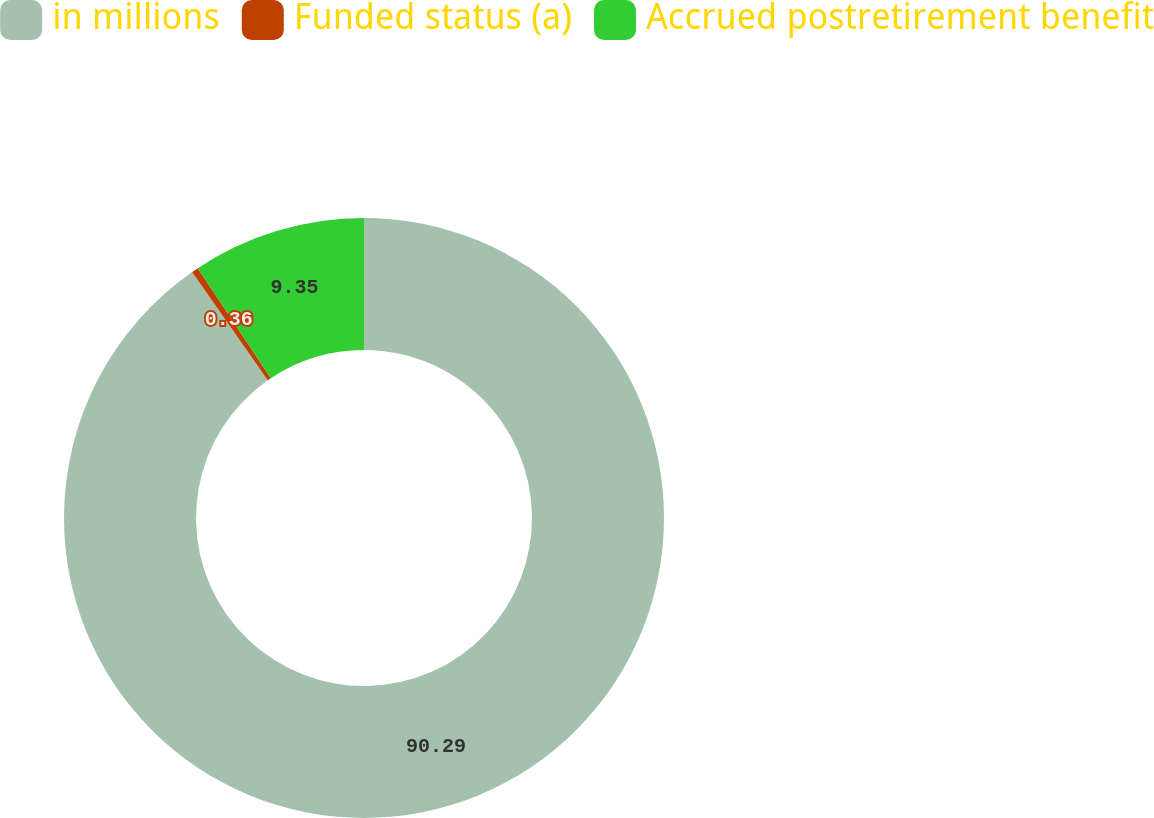<chart> <loc_0><loc_0><loc_500><loc_500><pie_chart><fcel>in millions<fcel>Funded status (a)<fcel>Accrued postretirement benefit<nl><fcel>90.29%<fcel>0.36%<fcel>9.35%<nl></chart> 